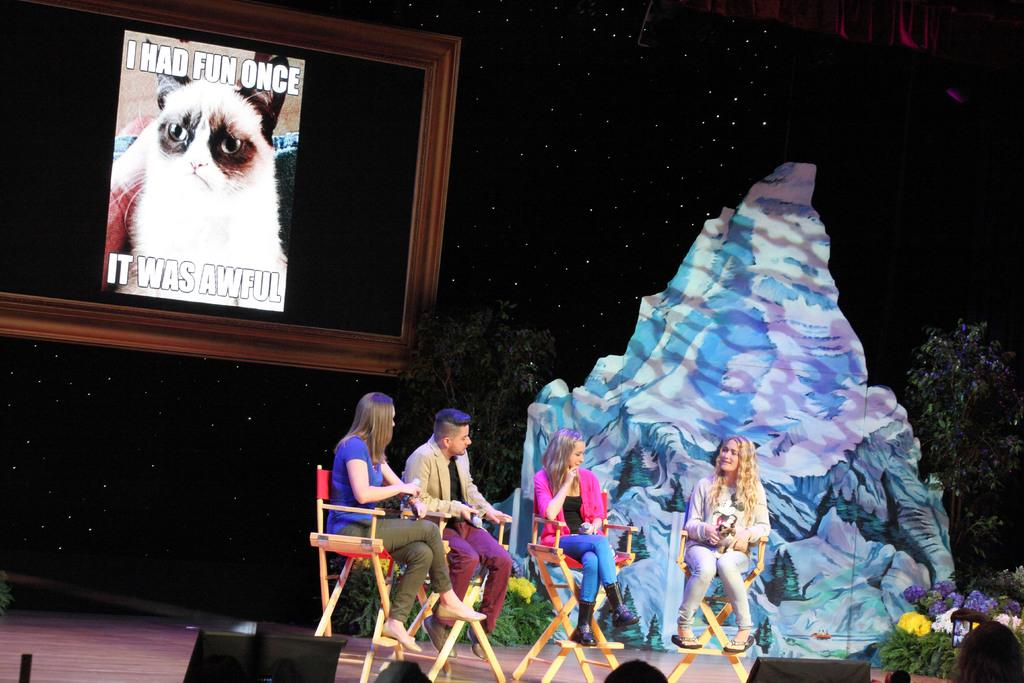What is happening in the foreground of the image? There are people sitting on the stage in the foreground. What can be seen in the background of the image? There is a poster and a frame in the background. Are there any people visible at the bottom side of the image? Yes, there are people at the bottom side of the image. What type of train is visible in the image? There are no trains present in the image. Can you read the letter that is being handed to the coach in the image? There is no coach or letter present in the image. 